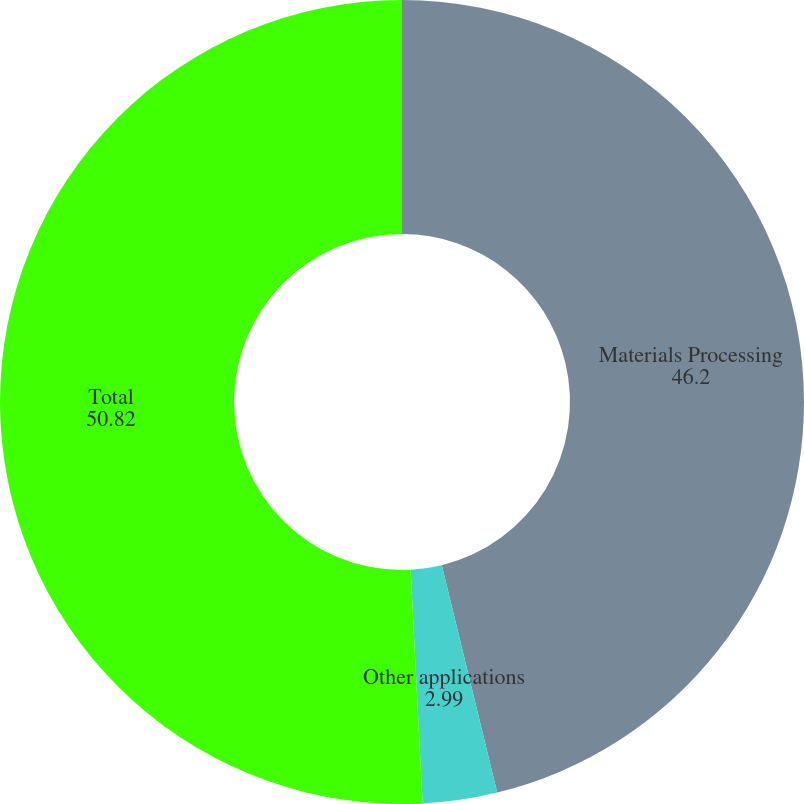<chart> <loc_0><loc_0><loc_500><loc_500><pie_chart><fcel>Materials Processing<fcel>Other applications<fcel>Total<nl><fcel>46.2%<fcel>2.99%<fcel>50.82%<nl></chart> 